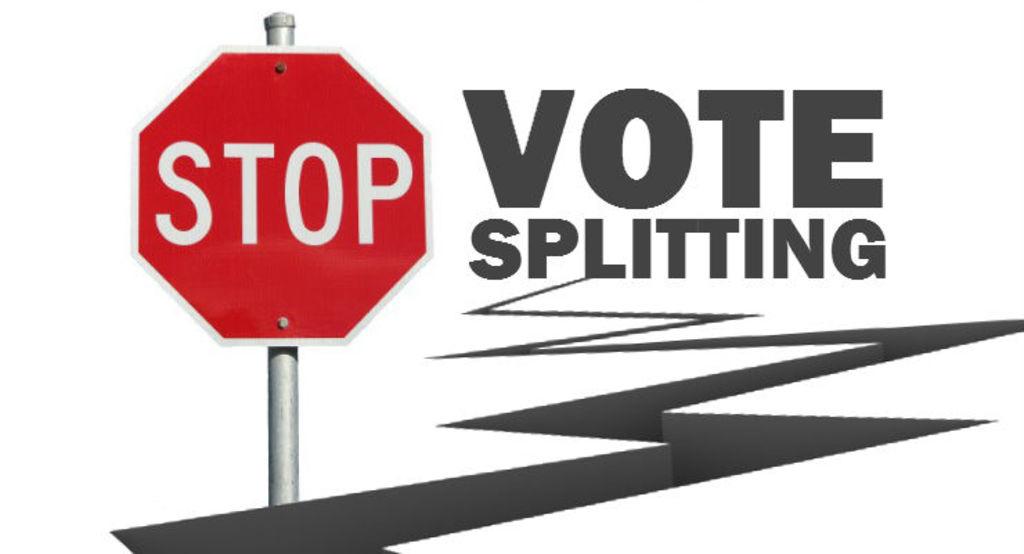What does the red octagon to the left say?
Keep it short and to the point. Stop. 